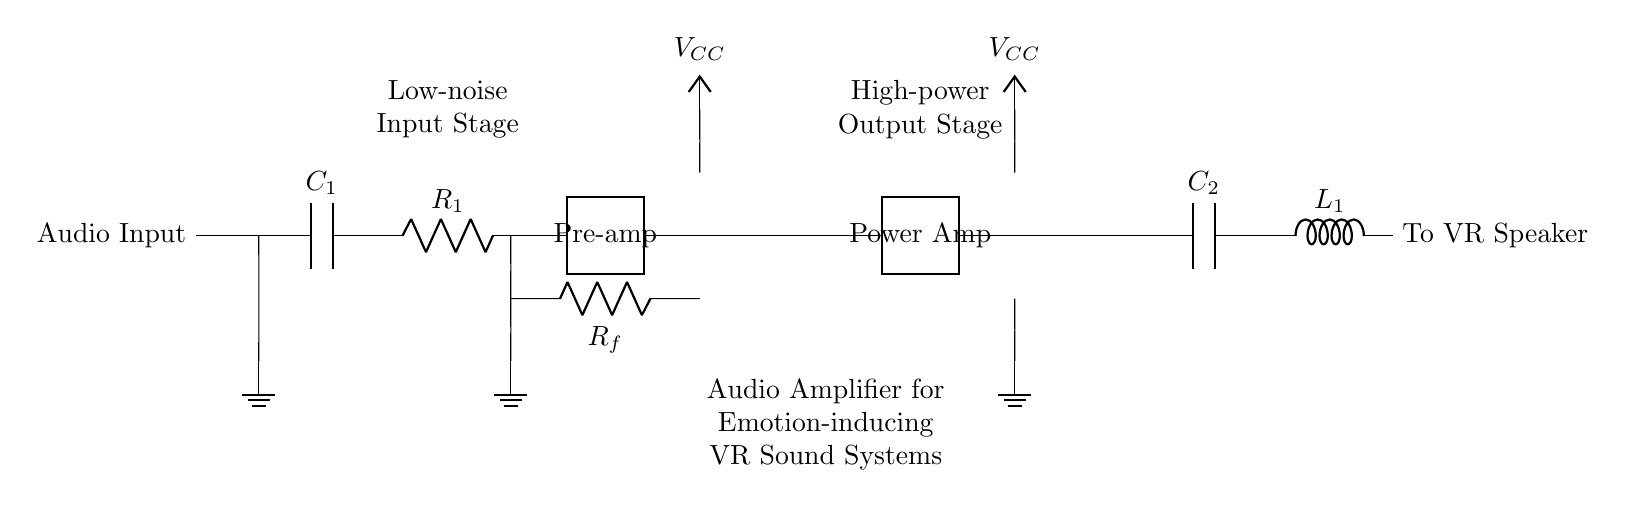What is the main function of the circuit? The main function is to amplify audio signals to enhance emotional experiences in virtual reality environments.
Answer: Amplification of audio What component provides power to the circuit? The circuit is powered by the voltage source labeled V_CC, connected at two points in the circuit.
Answer: V_CC How many stages are in this amplifier circuit? The circuit has three distinct stages: the input stage, the power amplifier stage, and the output stage.
Answer: Three stages What type of component is C_1? C_1 is a capacitor, which is used for coupling the audio input to the amplifier.
Answer: Capacitor What is the purpose of the feedback resistor R_f? R_f serves to stabilize the gain of the amplifier and improve linearity by providing feedback from the output to the input.
Answer: Stabilization of gain What is the load presented to the amplifier? The load consists of the components connected at the output stage, specifically the capacitor C_2 and the inductor L_1 leading to the speaker.
Answer: Capacitor and inductor How is the audio signal processed in the circuit? The audio signal is first coupled through C_1, amplified in the pre-amplifier, then further amplified in the power amplifier stage, and finally sent to the VR speaker through C_2 and L_1.
Answer: Amplified in stages 